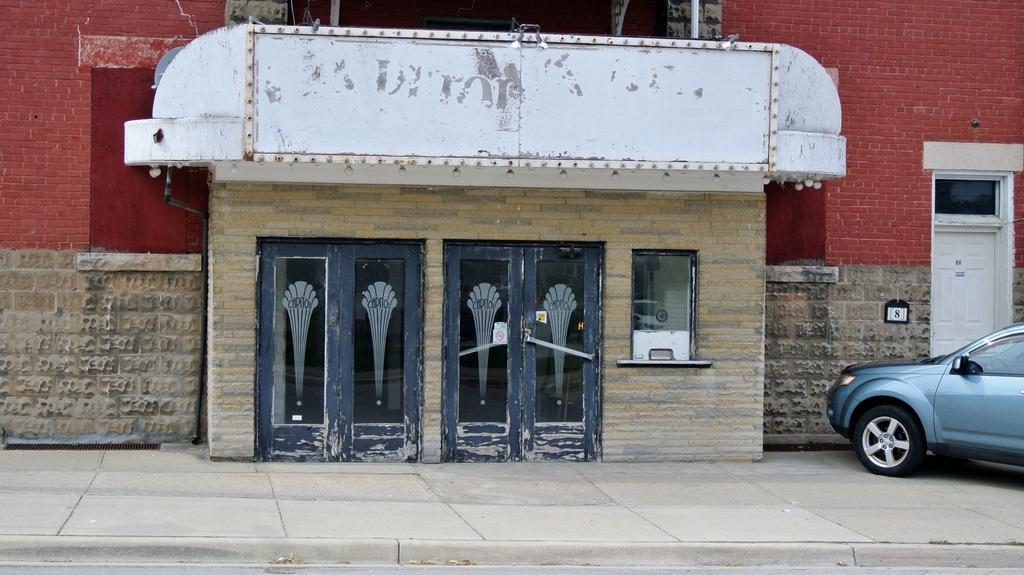What type of structure is present in the image? There is a building in the image. What features can be seen on the building? The building has doors and a window. What else is visible on the right side of the image? There is a car on the right side of the image. How many sheep are grazing in the cornfield next to the building in the image? There is no cornfield or sheep present in the image. 